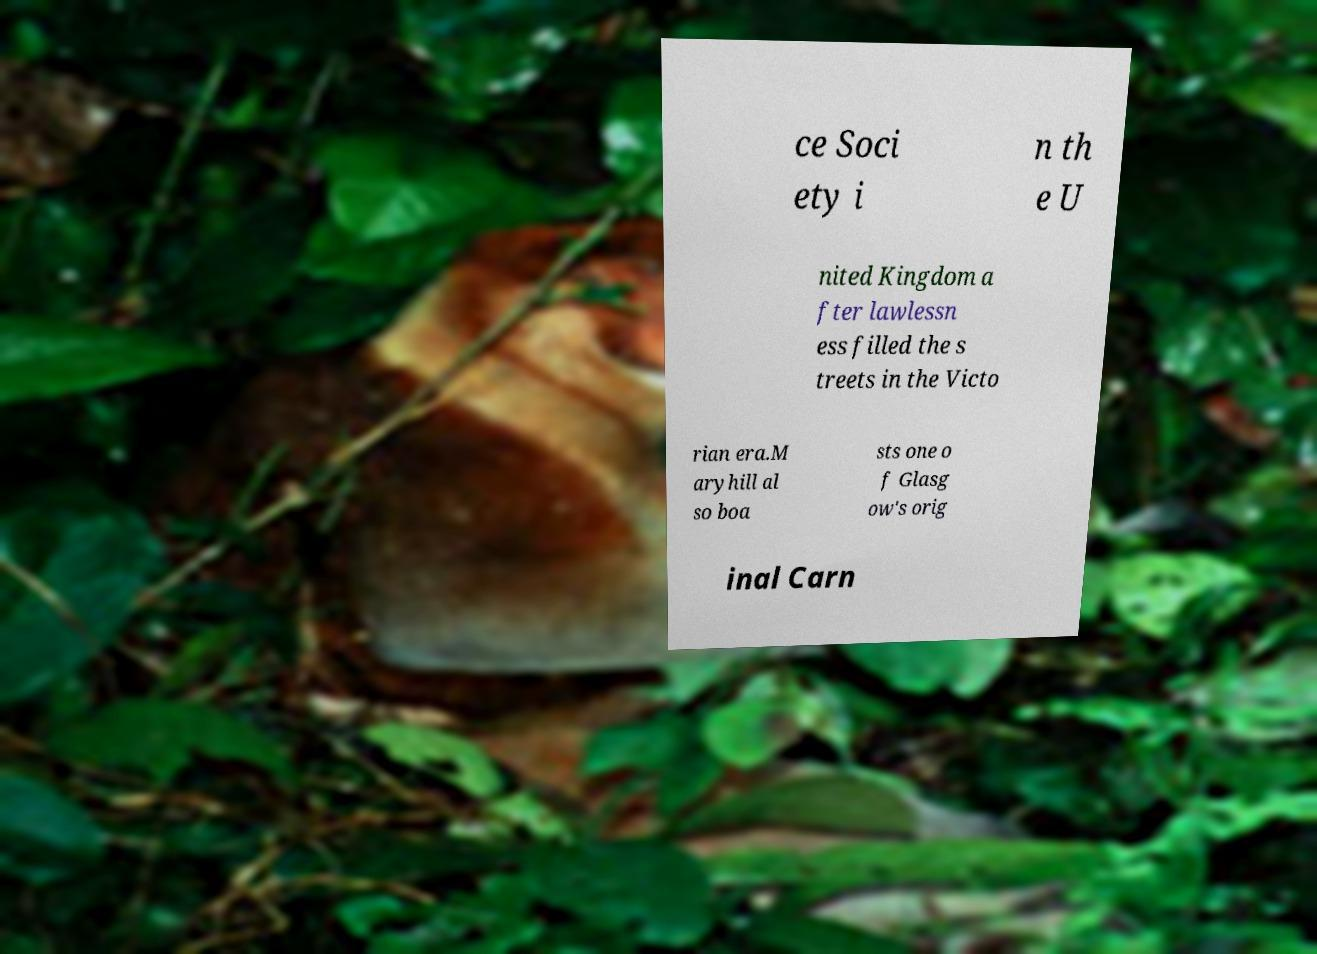For documentation purposes, I need the text within this image transcribed. Could you provide that? ce Soci ety i n th e U nited Kingdom a fter lawlessn ess filled the s treets in the Victo rian era.M aryhill al so boa sts one o f Glasg ow's orig inal Carn 